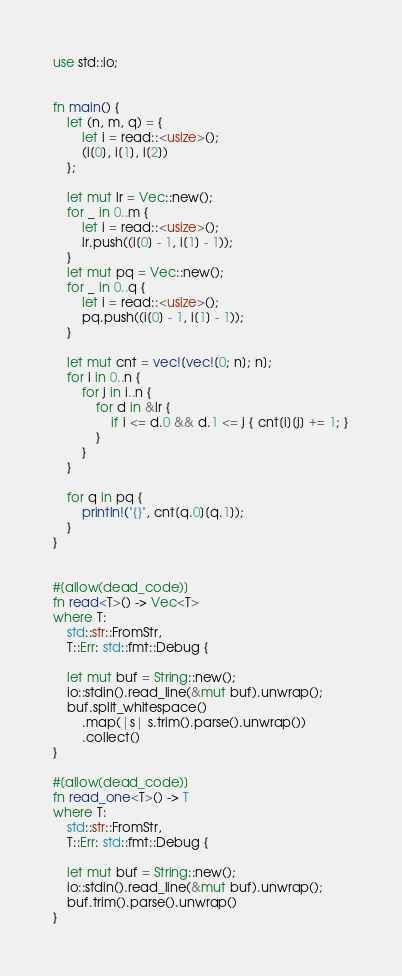<code> <loc_0><loc_0><loc_500><loc_500><_Rust_>use std::io;


fn main() {
    let (n, m, q) = {
        let i = read::<usize>();
        (i[0], i[1], i[2])
    };

    let mut lr = Vec::new();
    for _ in 0..m {
        let i = read::<usize>();
        lr.push((i[0] - 1, i[1] - 1));
    }
    let mut pq = Vec::new();
    for _ in 0..q {
        let i = read::<usize>();
        pq.push((i[0] - 1, i[1] - 1));
    }

    let mut cnt = vec![vec![0; n]; n];
    for i in 0..n {
        for j in i..n {
            for d in &lr {
                if i <= d.0 && d.1 <= j { cnt[i][j] += 1; }
            }
        }
    }

    for q in pq {
        println!("{}", cnt[q.0][q.1]);
    }
}


#[allow(dead_code)]
fn read<T>() -> Vec<T>
where T:
    std::str::FromStr,
    T::Err: std::fmt::Debug {

    let mut buf = String::new();
    io::stdin().read_line(&mut buf).unwrap();
    buf.split_whitespace()
        .map(|s| s.trim().parse().unwrap())
        .collect()
}

#[allow(dead_code)]
fn read_one<T>() -> T
where T:
    std::str::FromStr,
    T::Err: std::fmt::Debug {

    let mut buf = String::new();
    io::stdin().read_line(&mut buf).unwrap();
    buf.trim().parse().unwrap()
}</code> 